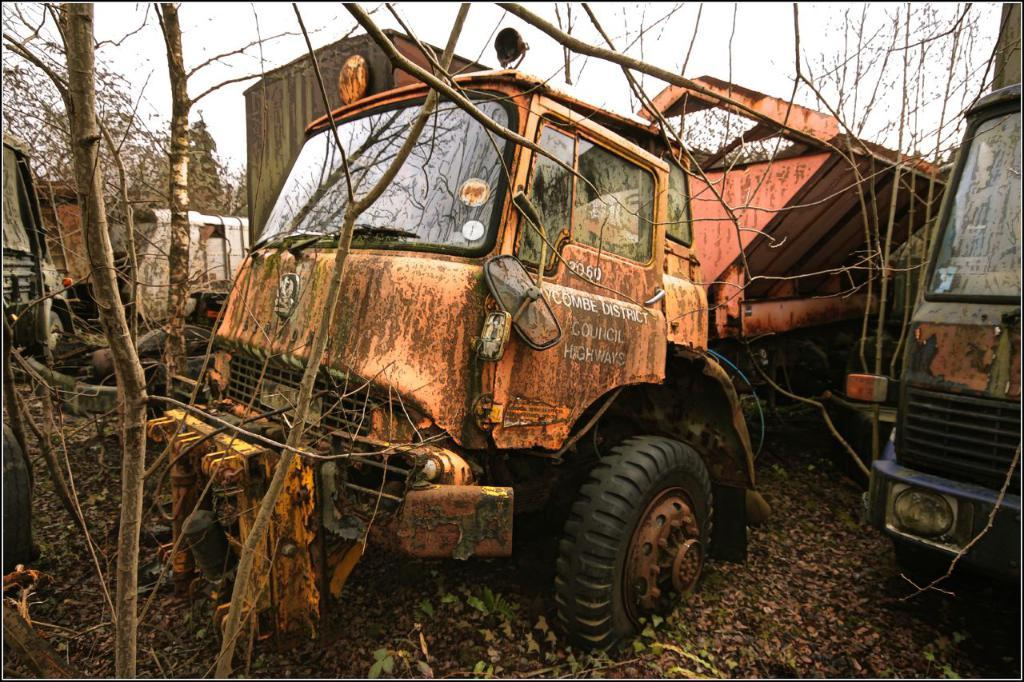What can be seen on the ground in the image? There are vehicles on the ground in the image. What type of vegetation is visible in the image? The branches of trees and a group of trees are visible in the image. What is present on the ground among the trees? There are dried leaves in the image. What is visible in the sky in the image? The sky is visible in the image, and it appears cloudy. What arithmetic problem is being solved by the trees in the image? There is no arithmetic problem being solved by the trees in the image; they are simply branches and a group of trees. What route are the vehicles taking in the image? The provided facts do not specify a route for the vehicles; they only mention that vehicles are present on the ground. 